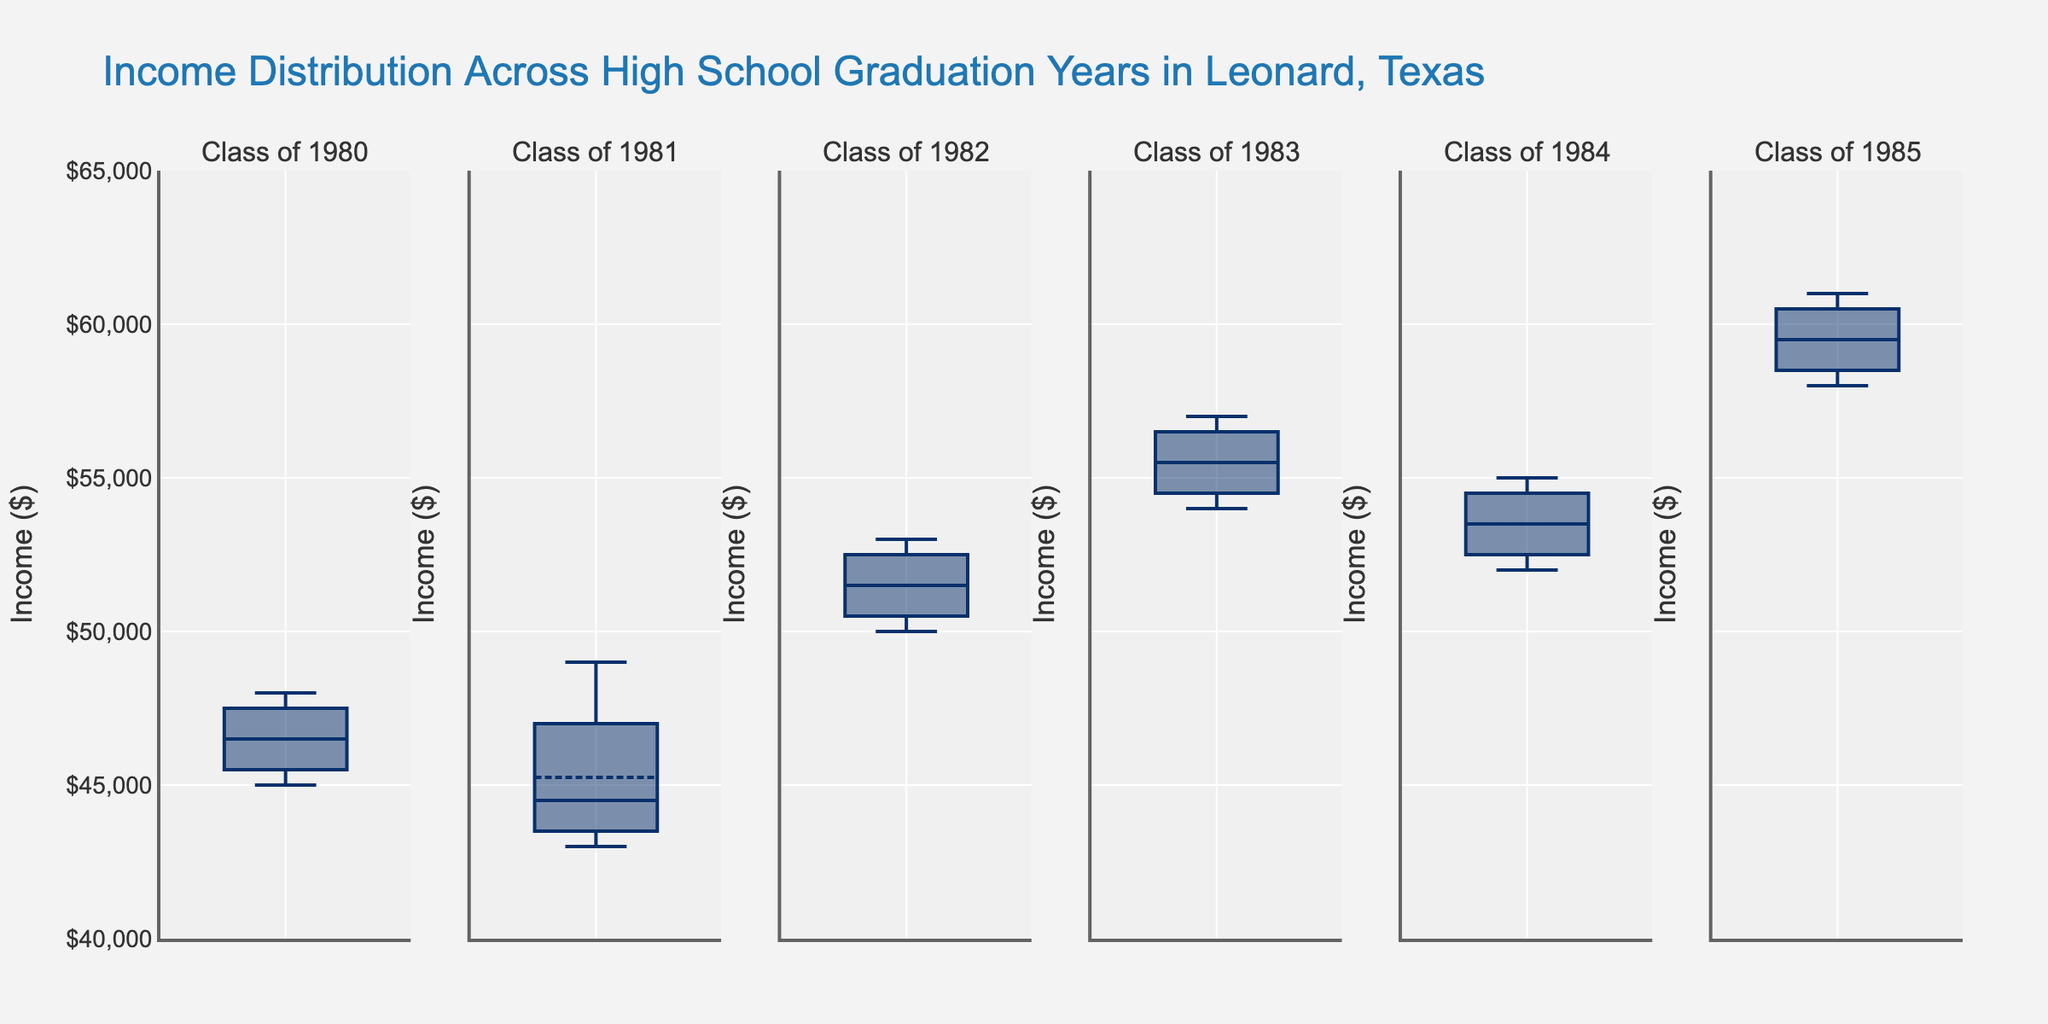Which class has the highest average income? To find the highest average income, look at the box plots and identify the class with the highest box mean line. The Class of 1985 has the highest box mean, indicating the highest average income.
Answer: Class of 1985 Which class has the lowest income range? The income range can be determined by the length of the box plot vertically. The Class of 1983 has the shortest box, indicating the lowest income range.
Answer: Class of 1983 What is the median income for the Class of 1982? The median income is located at the line inside the box plot. For the Class of 1982, the line is at $51,500.
Answer: $51,500 How do the income distributions of the Class of 1980 and Class of 1981 compare? To compare the distributions, observe the spread and median lines. The Class of 1980 has a higher median income but a similar range compared to the Class of 1981.
Answer: Class of 1980 has a higher median; ranges are similar Which class shows the most variability in income distribution? Variability can be assessed by looking at the interquartile range (IQR), identified by the length of the box plot. The Class of 1984 has the longest box plot, indicating the most variability.
Answer: Class of 1984 Is there a trend of increasing or decreasing average income over the years shown? By comparing the median income lines (boxmean) for each year, we observe that there is a general trend of increasing average income from Class of 1980 to Class of 1985.
Answer: Increasing Which year has the closest upper whisker to the $60,000 mark? Observe the upper whiskers and check which one is closest to $60,000. The Class of 1985 has an upper whisker closest to this value.
Answer: Class of 1985 What is the interquartile range (IQR) for the Class of 1983? IQR is the difference between the upper quartile (Q3) and lower quartile (Q1). For the Class of 1983, Q3 is $57,500 and Q1 is $54,500, so IQR is $57,500 - $54,500 = $3,000.
Answer: $3,000 